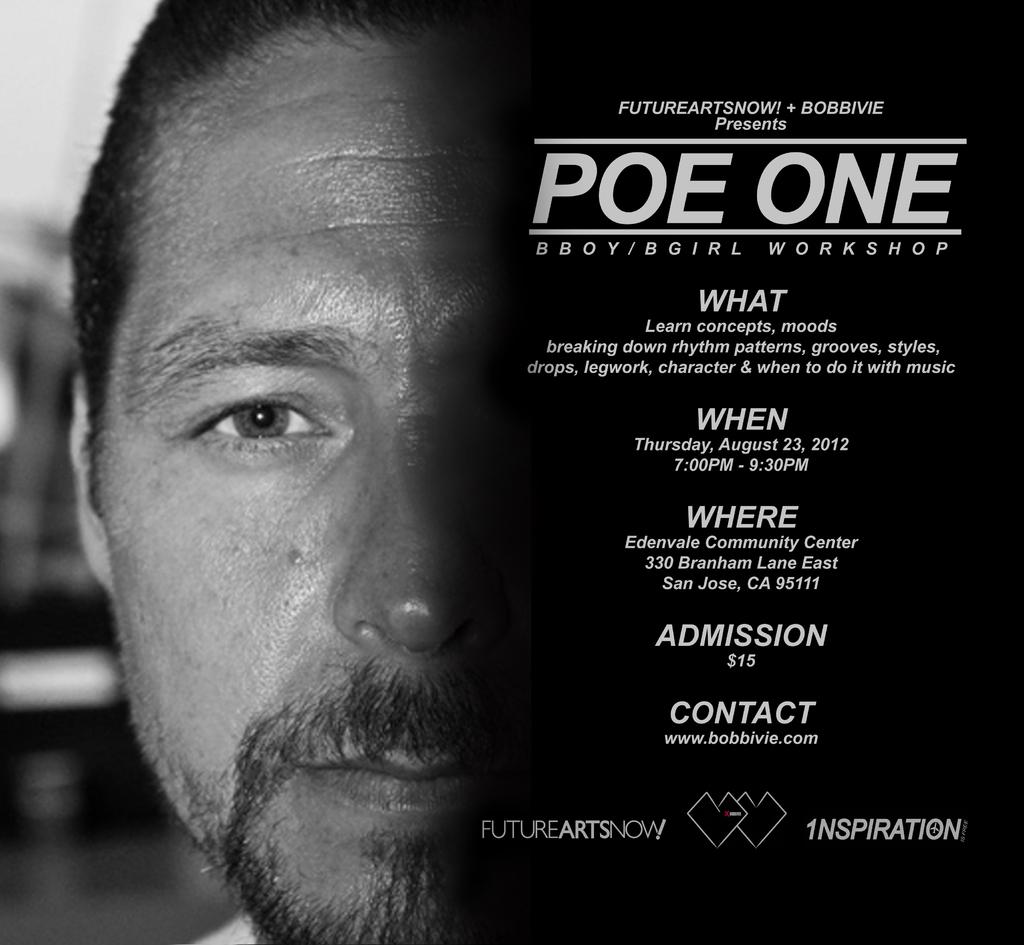What type of visual is the image? The image is a poster. Where is the information located on the poster? The information is on the right side of the poster. What can be seen on the left side of the poster? There is a person depicted on the left side of the poster. How many ladybugs can be seen on the poster? There are no ladybugs present on the poster. What unit of measurement is used to describe the person's height on the poster? There is no information about the person's height or any unit of measurement mentioned on the poster. 